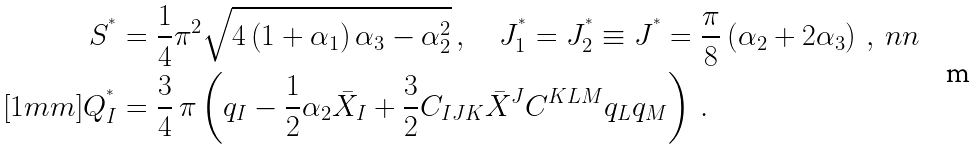Convert formula to latex. <formula><loc_0><loc_0><loc_500><loc_500>S ^ { ^ { * } } & = \frac { 1 } { 4 } \pi ^ { 2 } \sqrt { 4 \left ( 1 + \alpha _ { 1 } \right ) \alpha _ { 3 } - \alpha _ { 2 } ^ { 2 } } \, , \quad J _ { 1 } ^ { ^ { * } } = J _ { 2 } ^ { ^ { * } } \equiv J ^ { ^ { * } } = \frac { \pi } { 8 } \left ( \alpha _ { 2 } + 2 \alpha _ { 3 } \right ) \, , \ n n \\ [ 1 m m ] Q ^ { ^ { * } } _ { I } & = \frac { 3 } { 4 } \, \pi \left ( q _ { I } - \frac { 1 } { 2 } \alpha _ { 2 } \bar { X } _ { I } + \frac { 3 } { 2 } C _ { I J K } \bar { X } ^ { J } C ^ { K L M } q _ { L } q _ { M } \right ) \, .</formula> 